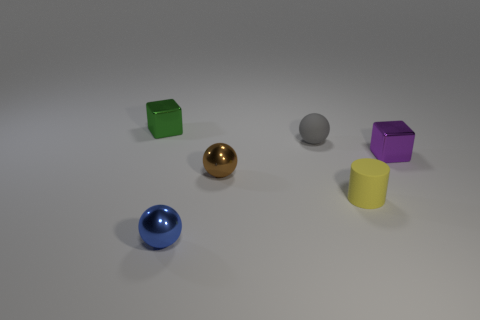How many things are either rubber cylinders or green shiny blocks?
Your response must be concise. 2. Is there any other thing that has the same material as the gray sphere?
Ensure brevity in your answer.  Yes. Are any shiny objects visible?
Your response must be concise. Yes. Are the block on the right side of the tiny green block and the small brown object made of the same material?
Your answer should be compact. Yes. Is there a yellow thing that has the same shape as the gray thing?
Your answer should be compact. No. Are there an equal number of yellow cylinders that are behind the yellow matte cylinder and cylinders?
Make the answer very short. No. There is a block in front of the small metal object that is behind the purple metal cube; what is it made of?
Provide a succinct answer. Metal. The small gray matte thing has what shape?
Provide a succinct answer. Sphere. Is the number of small green objects that are in front of the tiny yellow cylinder the same as the number of gray matte things in front of the green block?
Your response must be concise. No. Are there more blue metallic balls in front of the brown thing than big gray metal cylinders?
Offer a very short reply. Yes. 